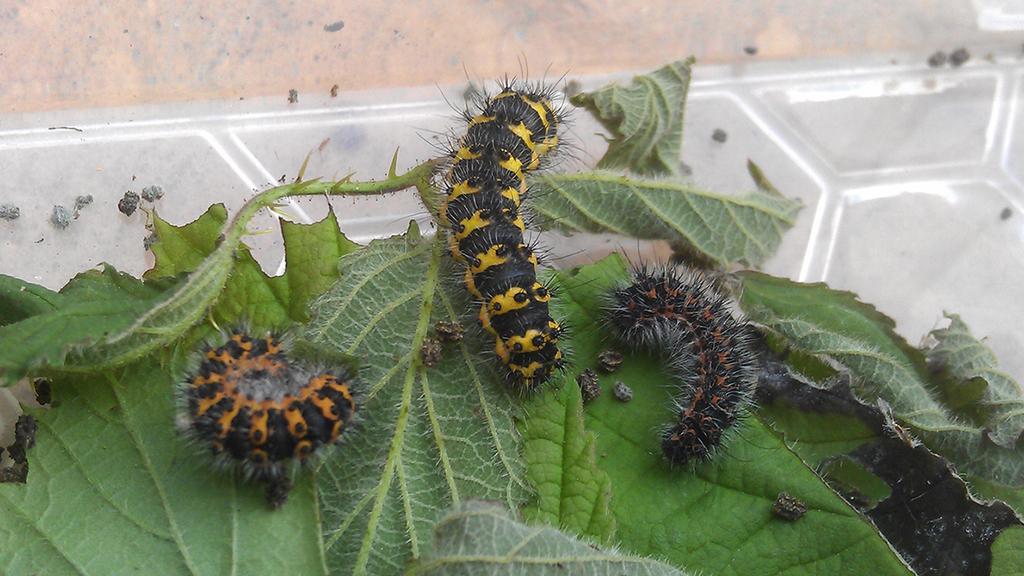In one or two sentences, can you explain what this image depicts? In this image I can see few insects in orange,black and yellow color. Insect are on the green color leaves. Back I can see a cream and grey and white surface. 